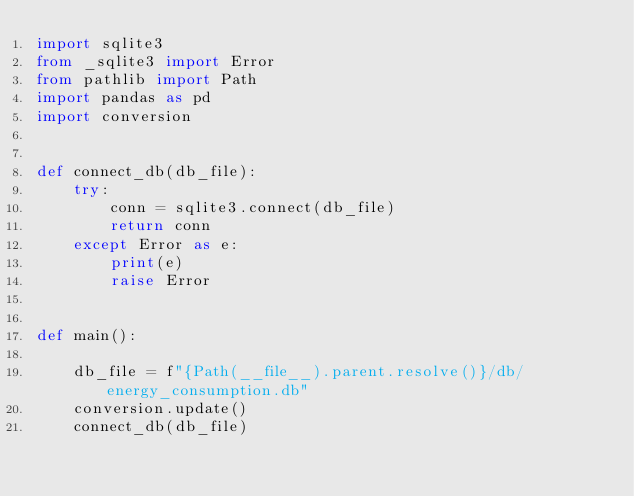Convert code to text. <code><loc_0><loc_0><loc_500><loc_500><_Python_>import sqlite3
from _sqlite3 import Error
from pathlib import Path
import pandas as pd
import conversion


def connect_db(db_file):
    try:
        conn = sqlite3.connect(db_file)
        return conn
    except Error as e:
        print(e)
        raise Error


def main():

    db_file = f"{Path(__file__).parent.resolve()}/db/energy_consumption.db"
    conversion.update()
    connect_db(db_file)

</code> 